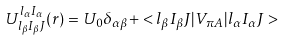<formula> <loc_0><loc_0><loc_500><loc_500>U ^ { l _ { \alpha } I _ { \alpha } } _ { l _ { \beta } I _ { \beta } J } ( r ) = U _ { 0 } \delta _ { \alpha \beta } + < l _ { \beta } I _ { \beta } J | V _ { \pi A } | l _ { \alpha } I _ { \alpha } J ></formula> 